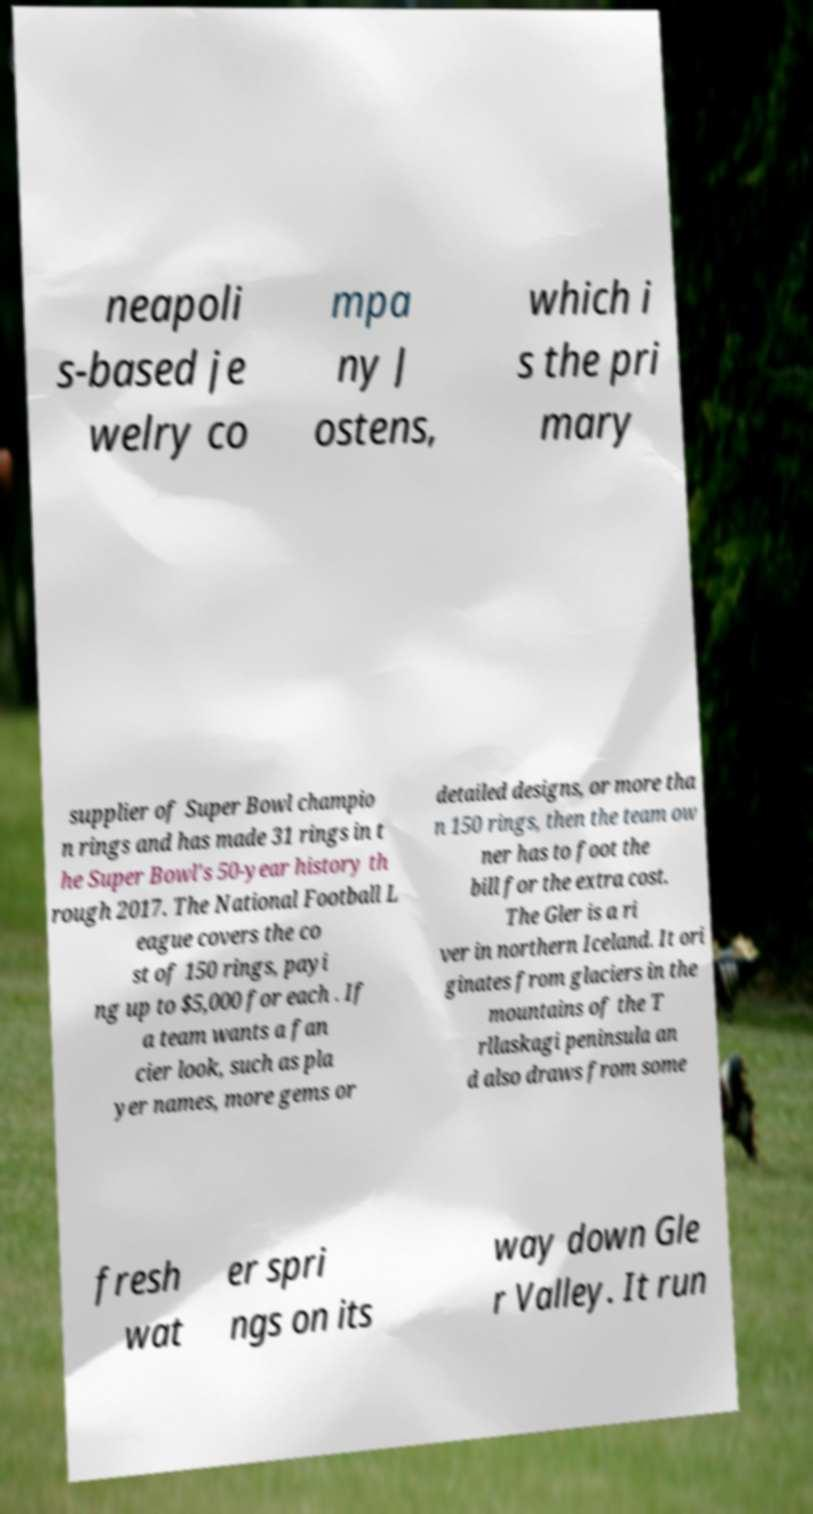For documentation purposes, I need the text within this image transcribed. Could you provide that? neapoli s-based je welry co mpa ny J ostens, which i s the pri mary supplier of Super Bowl champio n rings and has made 31 rings in t he Super Bowl's 50-year history th rough 2017. The National Football L eague covers the co st of 150 rings, payi ng up to $5,000 for each . If a team wants a fan cier look, such as pla yer names, more gems or detailed designs, or more tha n 150 rings, then the team ow ner has to foot the bill for the extra cost. The Gler is a ri ver in northern Iceland. It ori ginates from glaciers in the mountains of the T rllaskagi peninsula an d also draws from some fresh wat er spri ngs on its way down Gle r Valley. It run 